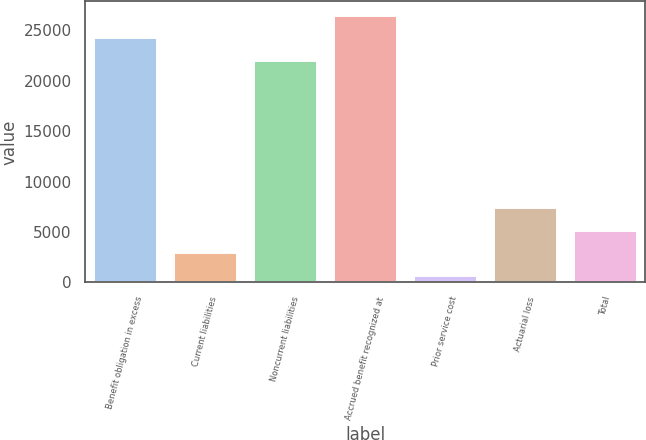Convert chart. <chart><loc_0><loc_0><loc_500><loc_500><bar_chart><fcel>Benefit obligation in excess<fcel>Current liabilities<fcel>Noncurrent liabilities<fcel>Accrued benefit recognized at<fcel>Prior service cost<fcel>Actuarial loss<fcel>Total<nl><fcel>24317.1<fcel>2982.1<fcel>22069<fcel>26565.2<fcel>734<fcel>7478.3<fcel>5230.2<nl></chart> 